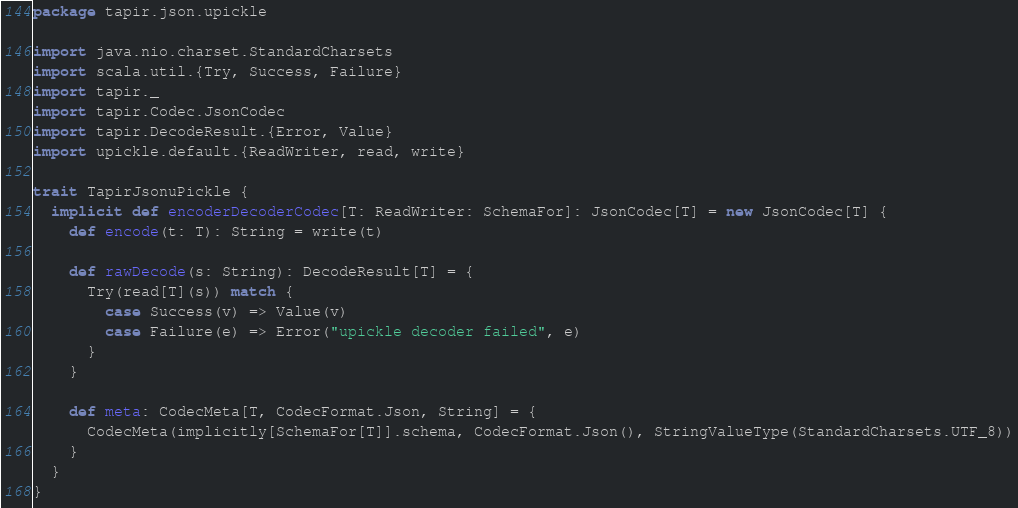Convert code to text. <code><loc_0><loc_0><loc_500><loc_500><_Scala_>package tapir.json.upickle

import java.nio.charset.StandardCharsets
import scala.util.{Try, Success, Failure}
import tapir._
import tapir.Codec.JsonCodec
import tapir.DecodeResult.{Error, Value}
import upickle.default.{ReadWriter, read, write}

trait TapirJsonuPickle {
  implicit def encoderDecoderCodec[T: ReadWriter: SchemaFor]: JsonCodec[T] = new JsonCodec[T] {
    def encode(t: T): String = write(t)

    def rawDecode(s: String): DecodeResult[T] = {
      Try(read[T](s)) match {
        case Success(v) => Value(v)
        case Failure(e) => Error("upickle decoder failed", e)
      }
    }

    def meta: CodecMeta[T, CodecFormat.Json, String] = {
      CodecMeta(implicitly[SchemaFor[T]].schema, CodecFormat.Json(), StringValueType(StandardCharsets.UTF_8))
    }
  }
}
</code> 